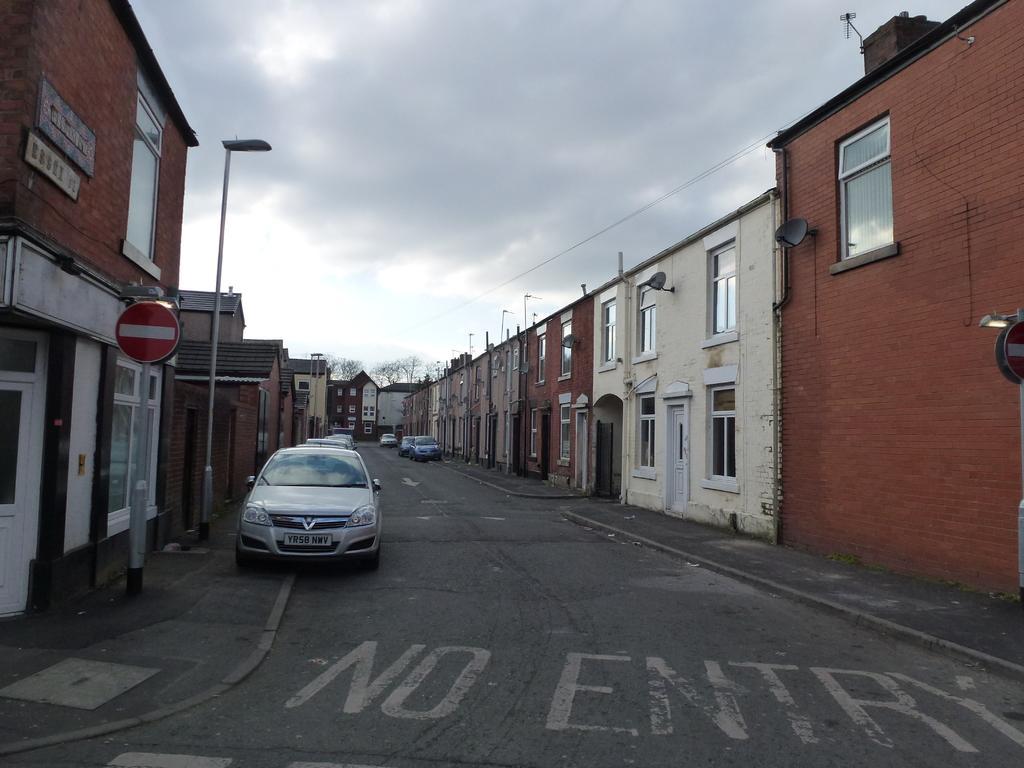How would you summarize this image in a sentence or two? In this image we can see the buildings, light poles, sign board and also the vehicles parked on the path. We can also see the wires and a cloudy sky and trees in the background. At the bottom we can see the text present on the road. 